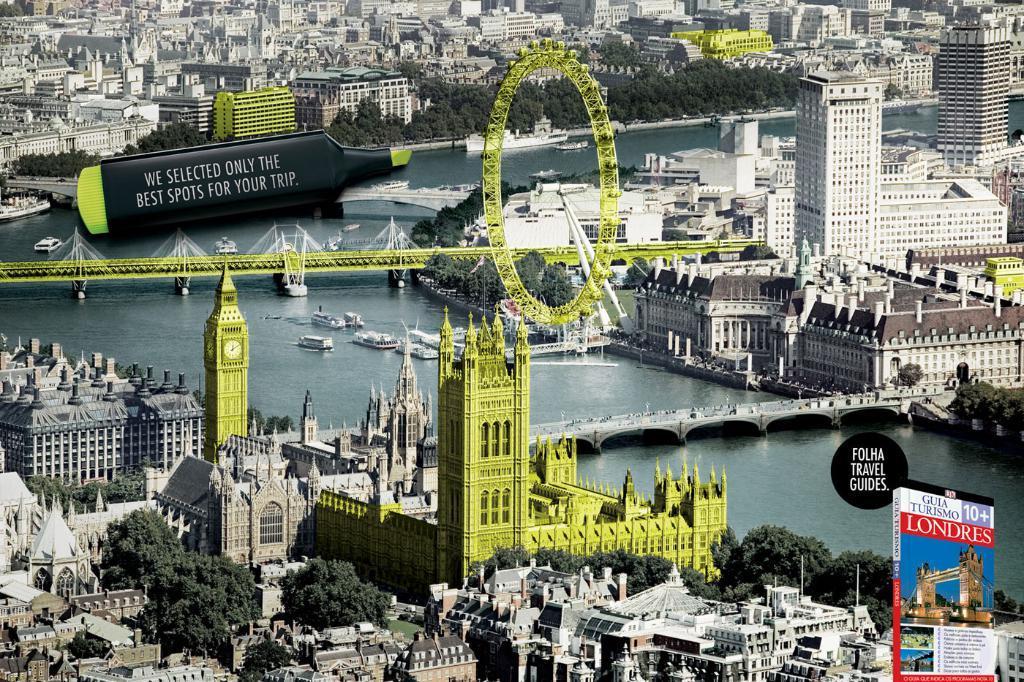Can you describe this image briefly? This is an advertisement. In the center of the image we can see bridges, giant wheel, water, boats. In the background of the image we can see buildings, trees, ground. At the bottom right corner we can see a book. At the top left corner bat and some text are there. 